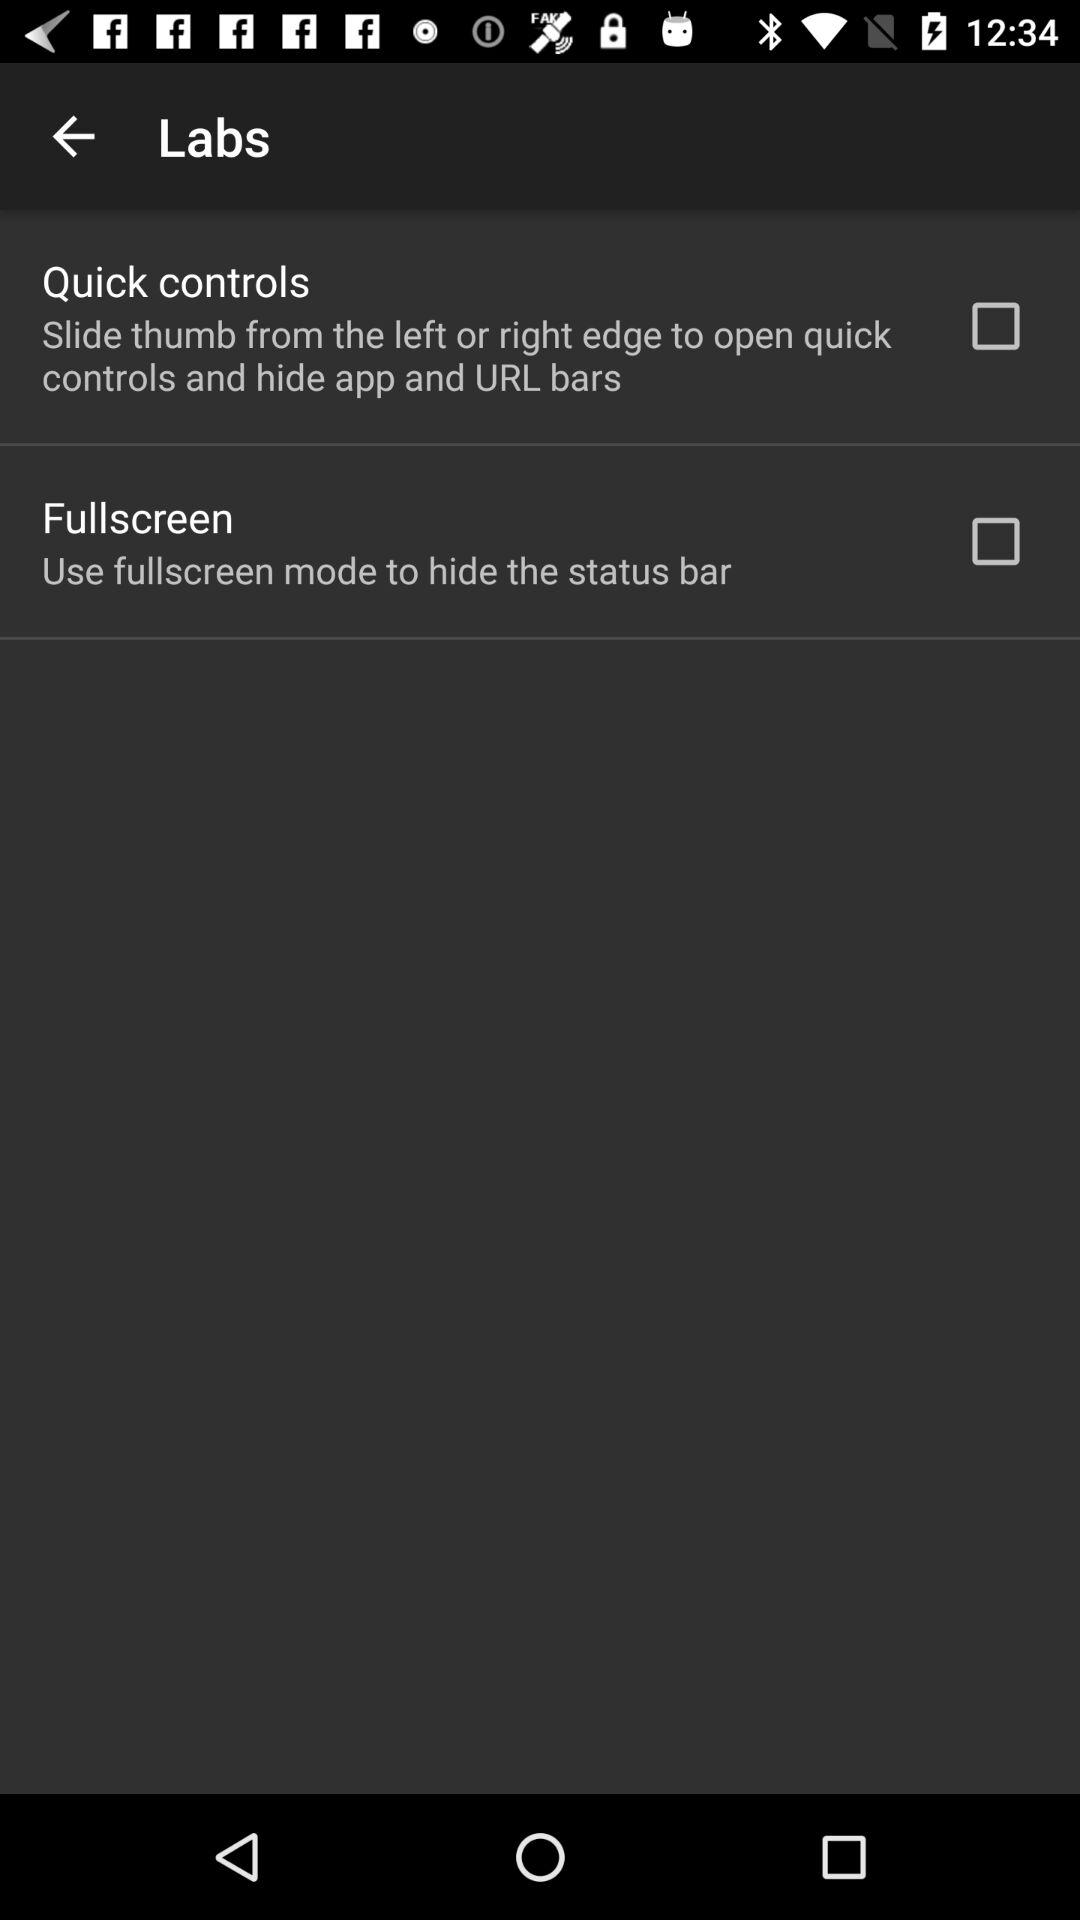What is the status of "Fullscreen"? The status is "off". 